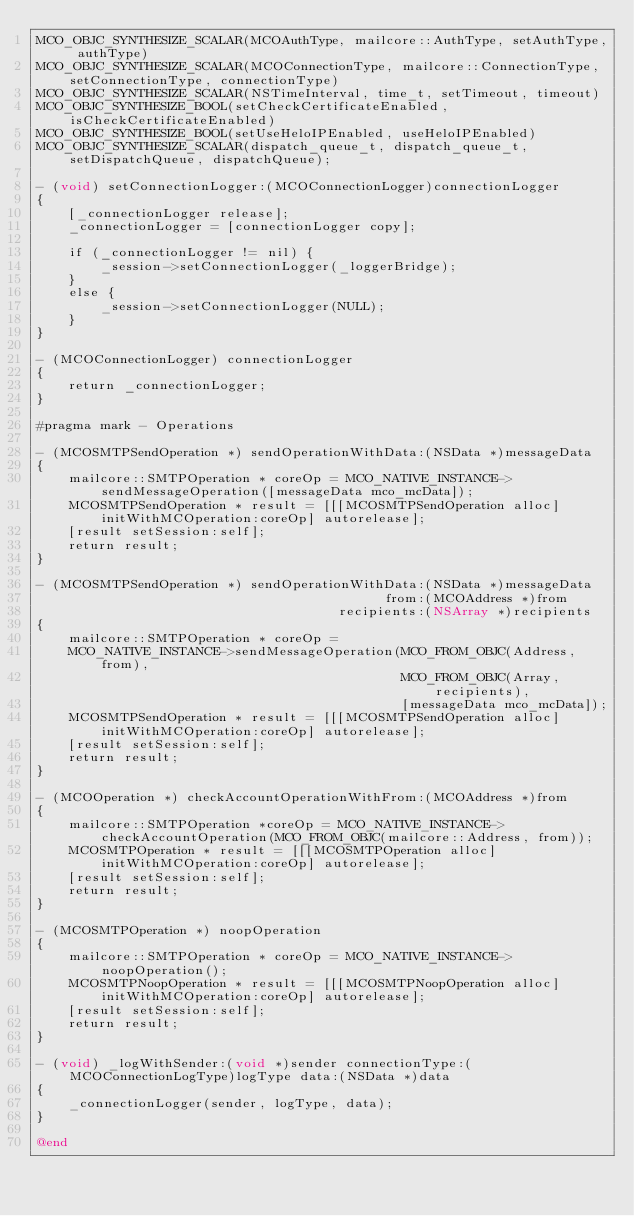<code> <loc_0><loc_0><loc_500><loc_500><_ObjectiveC_>MCO_OBJC_SYNTHESIZE_SCALAR(MCOAuthType, mailcore::AuthType, setAuthType, authType)
MCO_OBJC_SYNTHESIZE_SCALAR(MCOConnectionType, mailcore::ConnectionType, setConnectionType, connectionType)
MCO_OBJC_SYNTHESIZE_SCALAR(NSTimeInterval, time_t, setTimeout, timeout)
MCO_OBJC_SYNTHESIZE_BOOL(setCheckCertificateEnabled, isCheckCertificateEnabled)
MCO_OBJC_SYNTHESIZE_BOOL(setUseHeloIPEnabled, useHeloIPEnabled)
MCO_OBJC_SYNTHESIZE_SCALAR(dispatch_queue_t, dispatch_queue_t, setDispatchQueue, dispatchQueue);

- (void) setConnectionLogger:(MCOConnectionLogger)connectionLogger
{
    [_connectionLogger release];
    _connectionLogger = [connectionLogger copy];
    
    if (_connectionLogger != nil) {
        _session->setConnectionLogger(_loggerBridge);
    }
    else {
        _session->setConnectionLogger(NULL);
    }
}

- (MCOConnectionLogger) connectionLogger
{
    return _connectionLogger;
}

#pragma mark - Operations

- (MCOSMTPSendOperation *) sendOperationWithData:(NSData *)messageData
{
    mailcore::SMTPOperation * coreOp = MCO_NATIVE_INSTANCE->sendMessageOperation([messageData mco_mcData]);
    MCOSMTPSendOperation * result = [[[MCOSMTPSendOperation alloc] initWithMCOperation:coreOp] autorelease];
    [result setSession:self];
    return result;
}

- (MCOSMTPSendOperation *) sendOperationWithData:(NSData *)messageData
                                            from:(MCOAddress *)from
                                      recipients:(NSArray *)recipients
{
    mailcore::SMTPOperation * coreOp =
    MCO_NATIVE_INSTANCE->sendMessageOperation(MCO_FROM_OBJC(Address, from),
                                              MCO_FROM_OBJC(Array, recipients),
                                              [messageData mco_mcData]);
    MCOSMTPSendOperation * result = [[[MCOSMTPSendOperation alloc] initWithMCOperation:coreOp] autorelease];
    [result setSession:self];
    return result;
}

- (MCOOperation *) checkAccountOperationWithFrom:(MCOAddress *)from
{
    mailcore::SMTPOperation *coreOp = MCO_NATIVE_INSTANCE->checkAccountOperation(MCO_FROM_OBJC(mailcore::Address, from));
    MCOSMTPOperation * result = [[[MCOSMTPOperation alloc] initWithMCOperation:coreOp] autorelease];
    [result setSession:self];
    return result;
}

- (MCOSMTPOperation *) noopOperation
{
    mailcore::SMTPOperation * coreOp = MCO_NATIVE_INSTANCE->noopOperation();
    MCOSMTPNoopOperation * result = [[[MCOSMTPNoopOperation alloc] initWithMCOperation:coreOp] autorelease];
    [result setSession:self];
    return result;
}

- (void) _logWithSender:(void *)sender connectionType:(MCOConnectionLogType)logType data:(NSData *)data
{
    _connectionLogger(sender, logType, data);
}

@end
</code> 